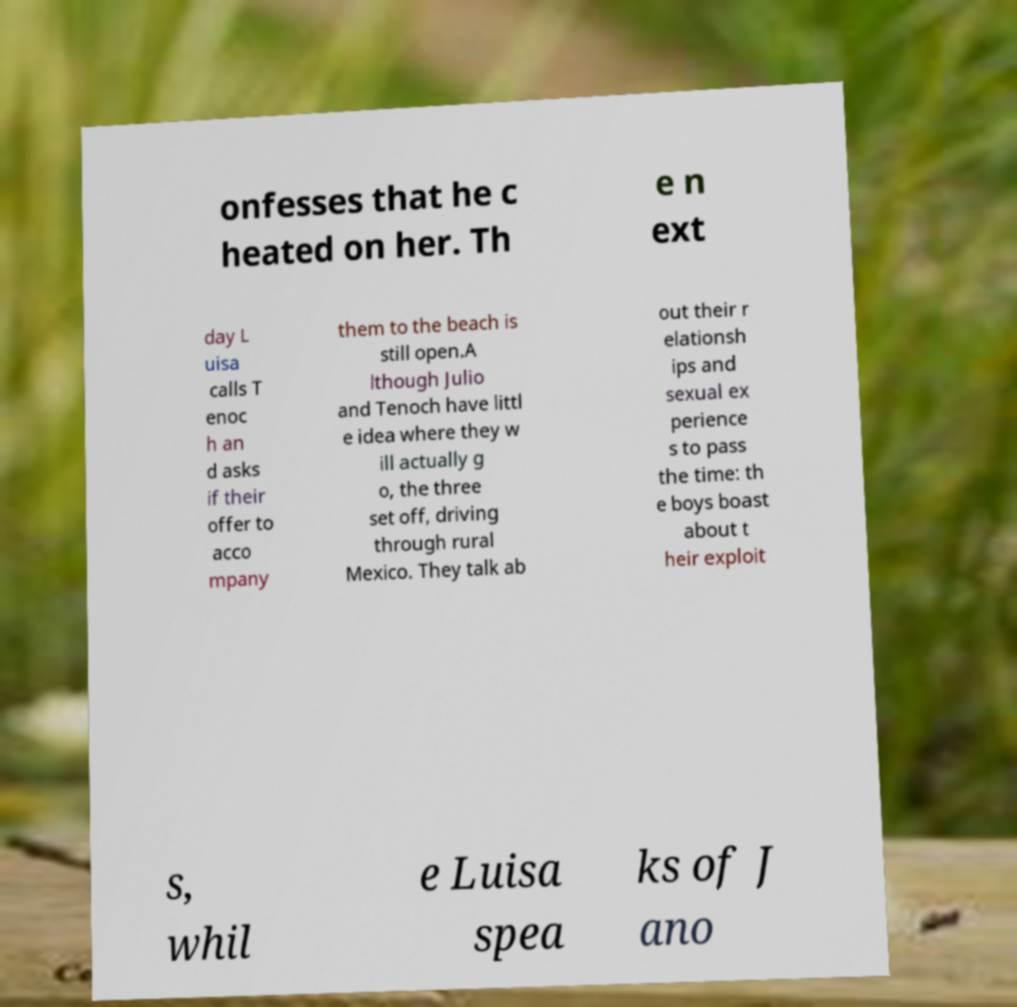Could you assist in decoding the text presented in this image and type it out clearly? onfesses that he c heated on her. Th e n ext day L uisa calls T enoc h an d asks if their offer to acco mpany them to the beach is still open.A lthough Julio and Tenoch have littl e idea where they w ill actually g o, the three set off, driving through rural Mexico. They talk ab out their r elationsh ips and sexual ex perience s to pass the time: th e boys boast about t heir exploit s, whil e Luisa spea ks of J ano 